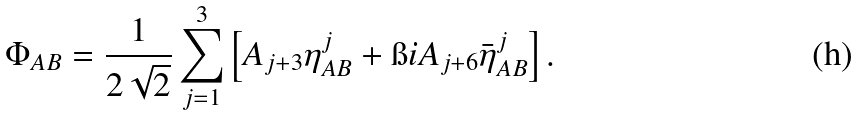Convert formula to latex. <formula><loc_0><loc_0><loc_500><loc_500>\Phi _ { A B } = \frac { 1 } { 2 \sqrt { 2 } } \sum _ { j = 1 } ^ { 3 } \left [ A _ { j + 3 } \eta ^ { j } _ { A B } + \i i A _ { j + 6 } \bar { \eta } ^ { j } _ { A B } \right ] .</formula> 